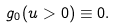<formula> <loc_0><loc_0><loc_500><loc_500>g _ { 0 } ( u > 0 ) \equiv 0 .</formula> 